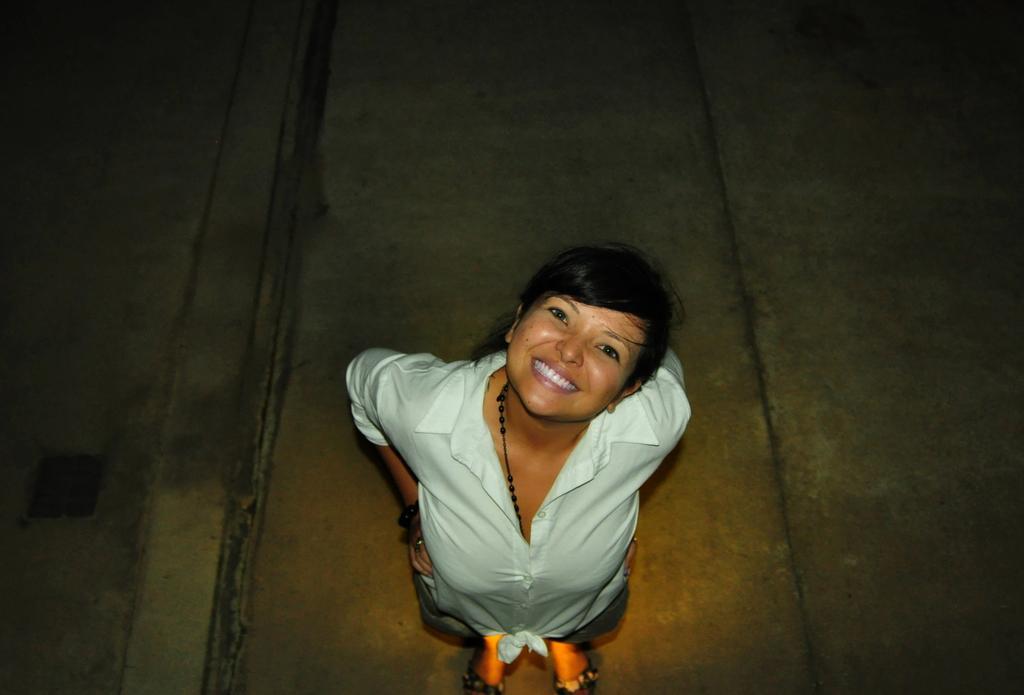Can you describe this image briefly? In this image, there is a person standing and wearing clothes. 